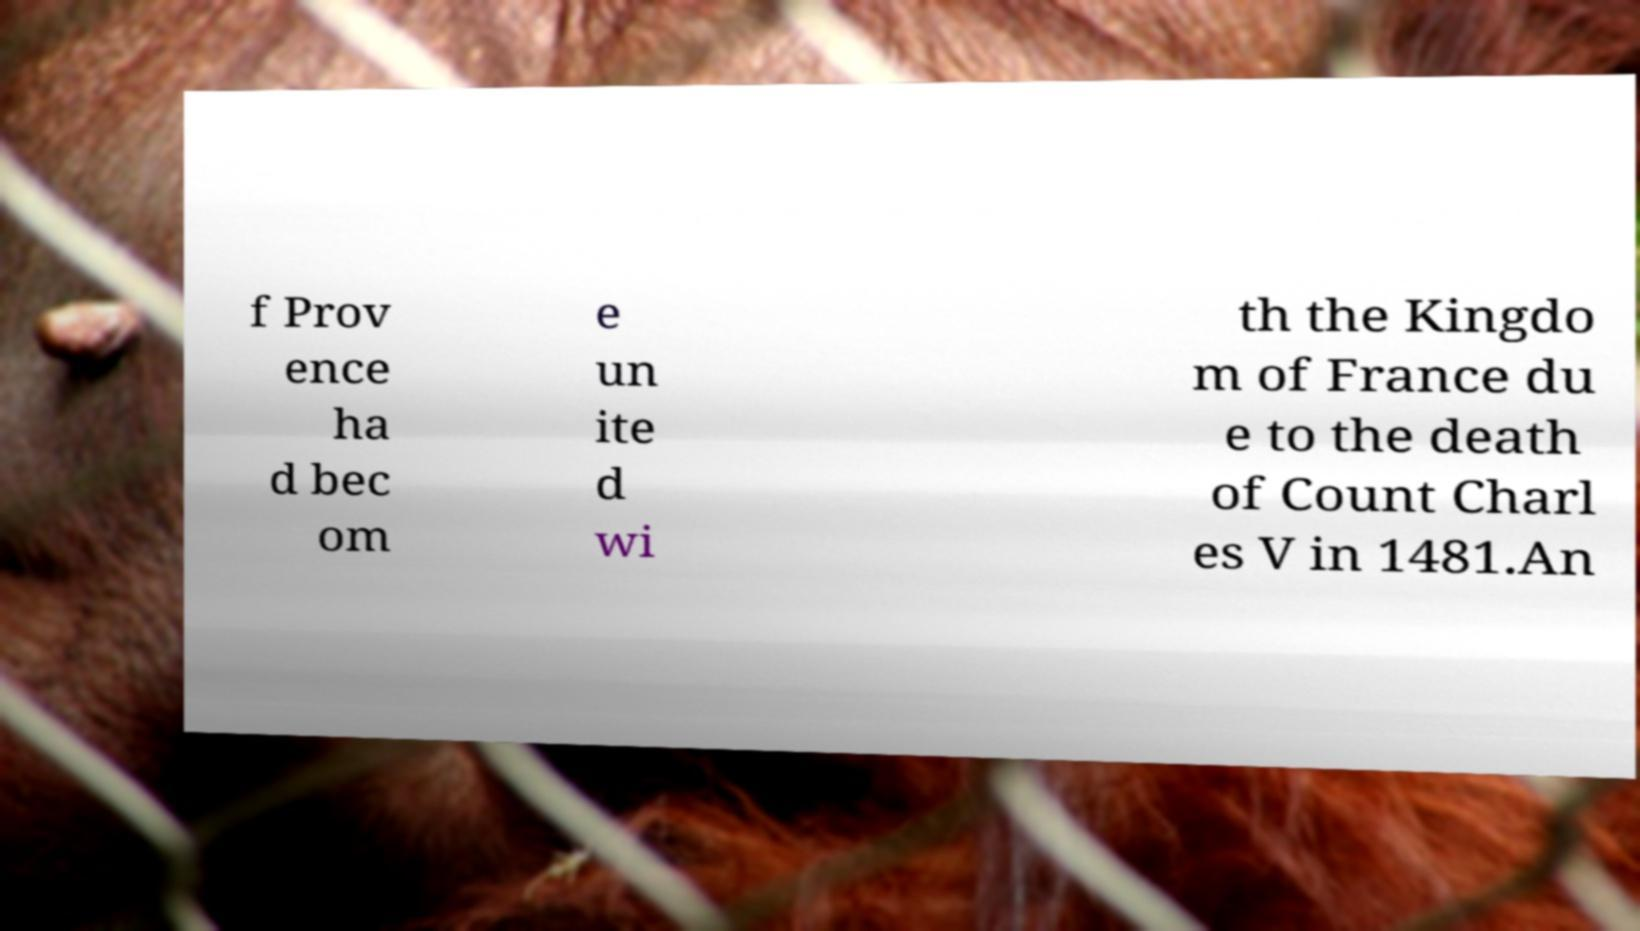Please identify and transcribe the text found in this image. f Prov ence ha d bec om e un ite d wi th the Kingdo m of France du e to the death of Count Charl es V in 1481.An 